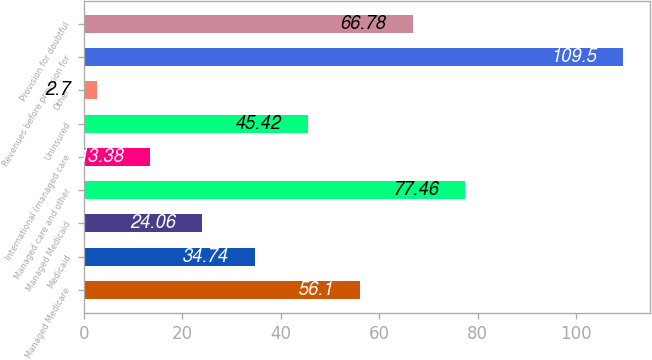Convert chart. <chart><loc_0><loc_0><loc_500><loc_500><bar_chart><fcel>Managed Medicare<fcel>Medicaid<fcel>Managed Medicaid<fcel>Managed care and other<fcel>International (managed care<fcel>Uninsured<fcel>Other<fcel>Revenues before provision for<fcel>Provision for doubtful<nl><fcel>56.1<fcel>34.74<fcel>24.06<fcel>77.46<fcel>13.38<fcel>45.42<fcel>2.7<fcel>109.5<fcel>66.78<nl></chart> 